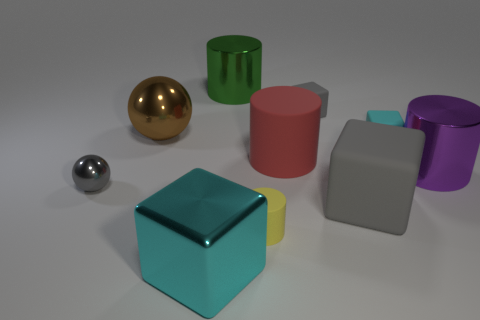Is there a green thing of the same shape as the large cyan thing?
Provide a short and direct response. No. How many cylinders are there?
Make the answer very short. 4. Do the cylinder in front of the large rubber block and the small gray cube have the same material?
Your answer should be compact. Yes. Are there any yellow rubber cylinders of the same size as the metallic block?
Keep it short and to the point. No. Is the shape of the large red thing the same as the large rubber object that is in front of the purple object?
Make the answer very short. No. Is there a small object in front of the gray thing left of the cyan thing in front of the purple metallic cylinder?
Provide a succinct answer. Yes. The yellow cylinder has what size?
Offer a terse response. Small. How many other objects are the same color as the tiny shiny sphere?
Offer a terse response. 2. There is a red thing that is on the right side of the brown shiny sphere; is its shape the same as the gray metallic thing?
Ensure brevity in your answer.  No. There is another shiny object that is the same shape as the large gray object; what is its color?
Offer a terse response. Cyan. 